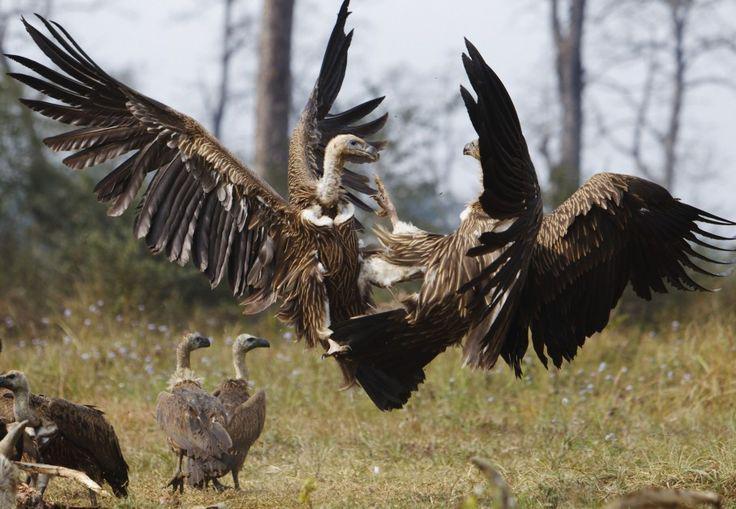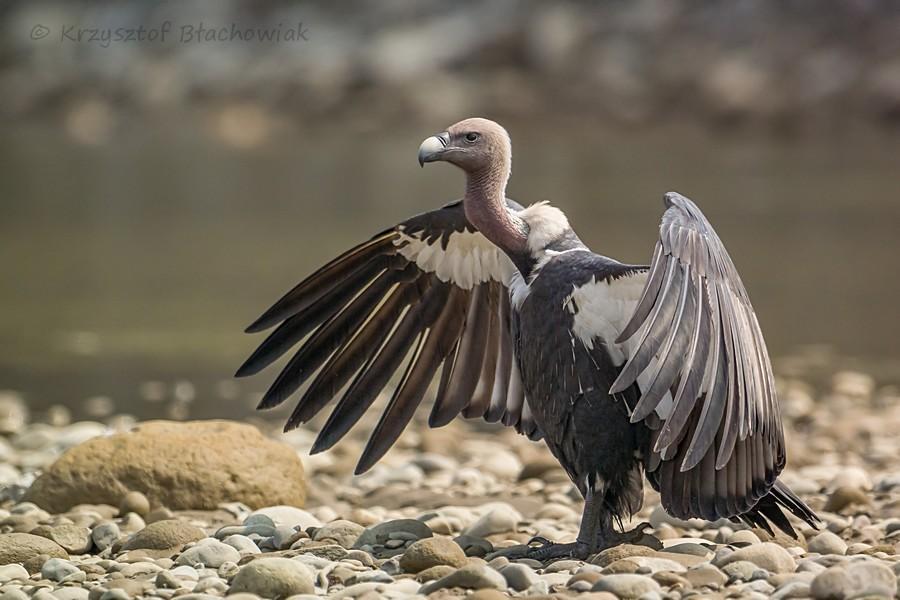The first image is the image on the left, the second image is the image on the right. For the images displayed, is the sentence "The left and right image contains the same number of vaulters" factually correct? Answer yes or no. No. The first image is the image on the left, the second image is the image on the right. Analyze the images presented: Is the assertion "In all images at least one bird has its wings open, and in one image that bird is on the ground and in the other it is in the air." valid? Answer yes or no. Yes. 